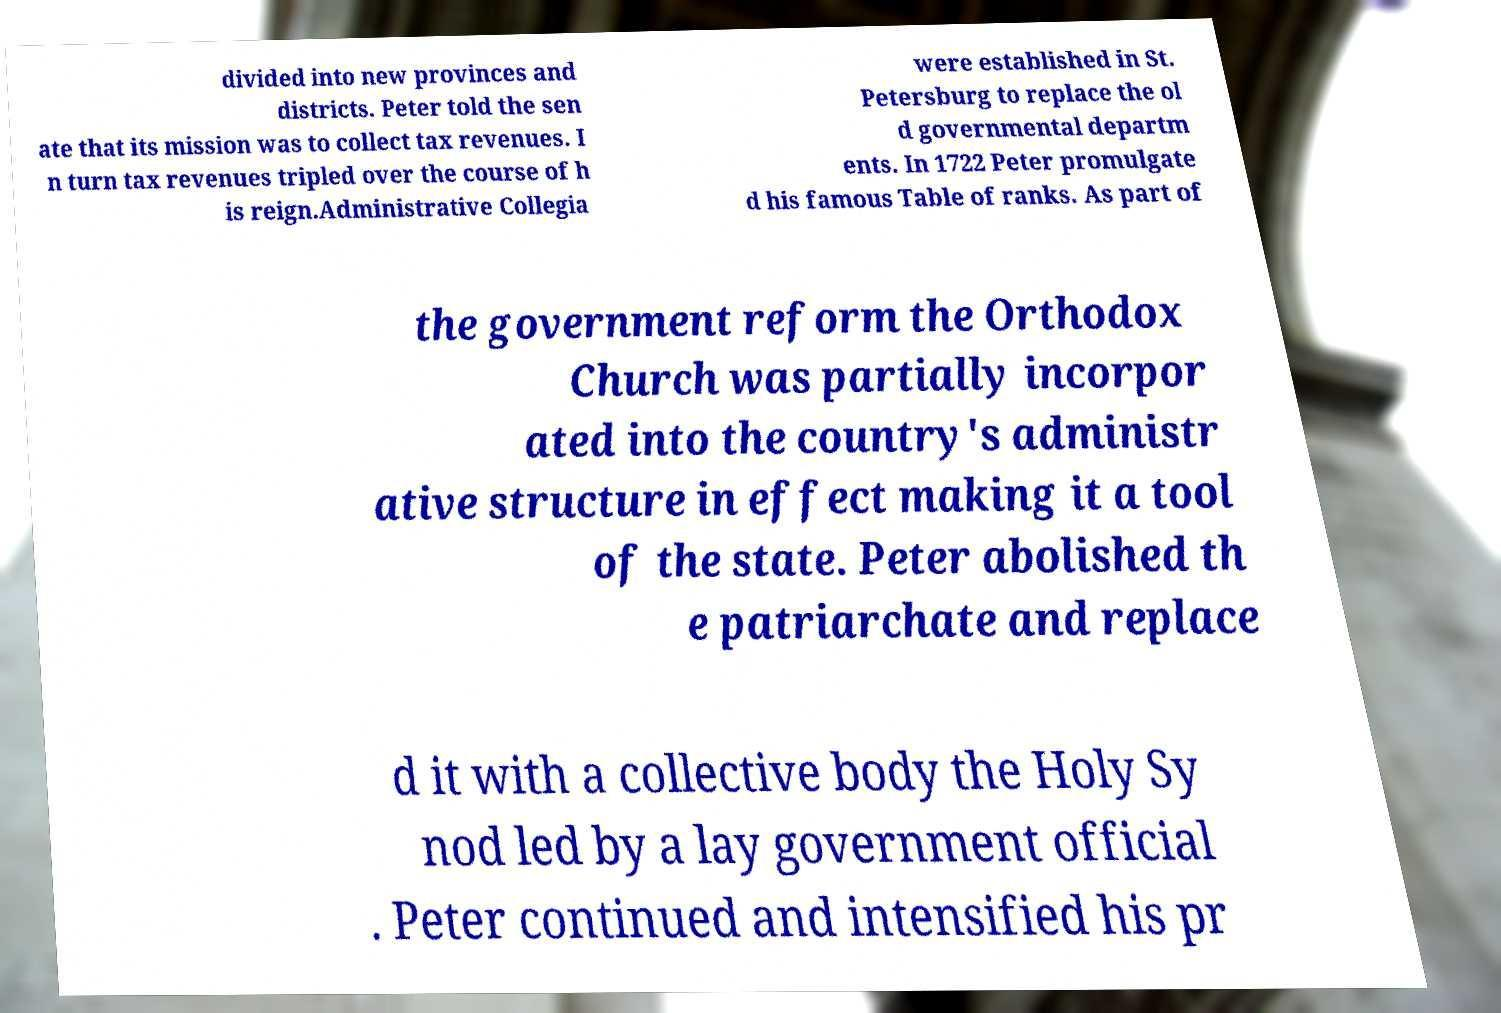What messages or text are displayed in this image? I need them in a readable, typed format. divided into new provinces and districts. Peter told the sen ate that its mission was to collect tax revenues. I n turn tax revenues tripled over the course of h is reign.Administrative Collegia were established in St. Petersburg to replace the ol d governmental departm ents. In 1722 Peter promulgate d his famous Table of ranks. As part of the government reform the Orthodox Church was partially incorpor ated into the country's administr ative structure in effect making it a tool of the state. Peter abolished th e patriarchate and replace d it with a collective body the Holy Sy nod led by a lay government official . Peter continued and intensified his pr 